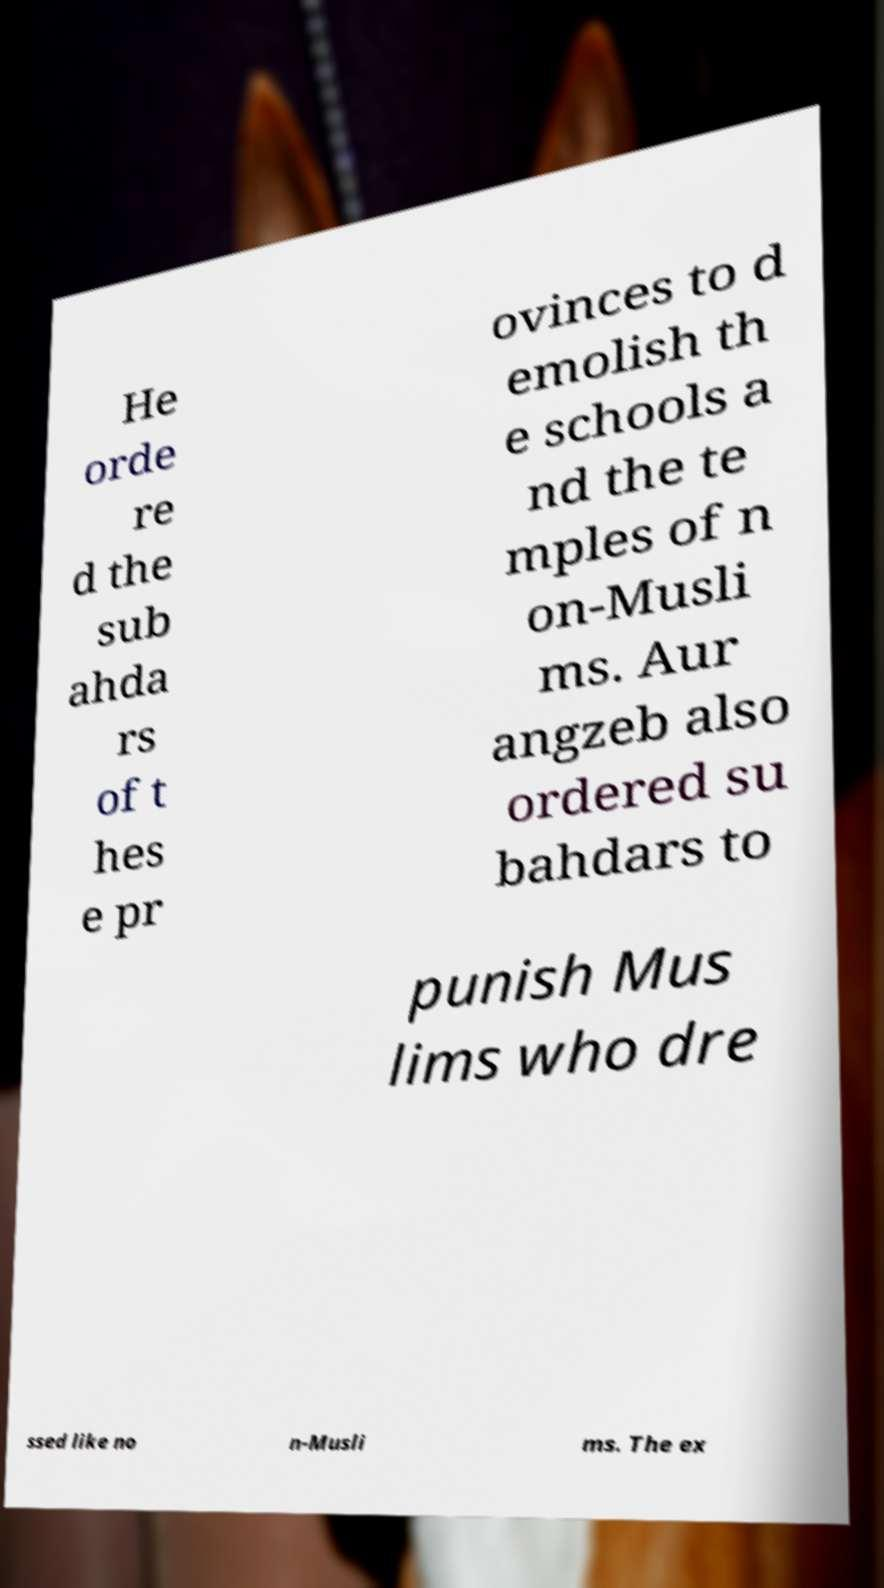What messages or text are displayed in this image? I need them in a readable, typed format. He orde re d the sub ahda rs of t hes e pr ovinces to d emolish th e schools a nd the te mples of n on-Musli ms. Aur angzeb also ordered su bahdars to punish Mus lims who dre ssed like no n-Musli ms. The ex 